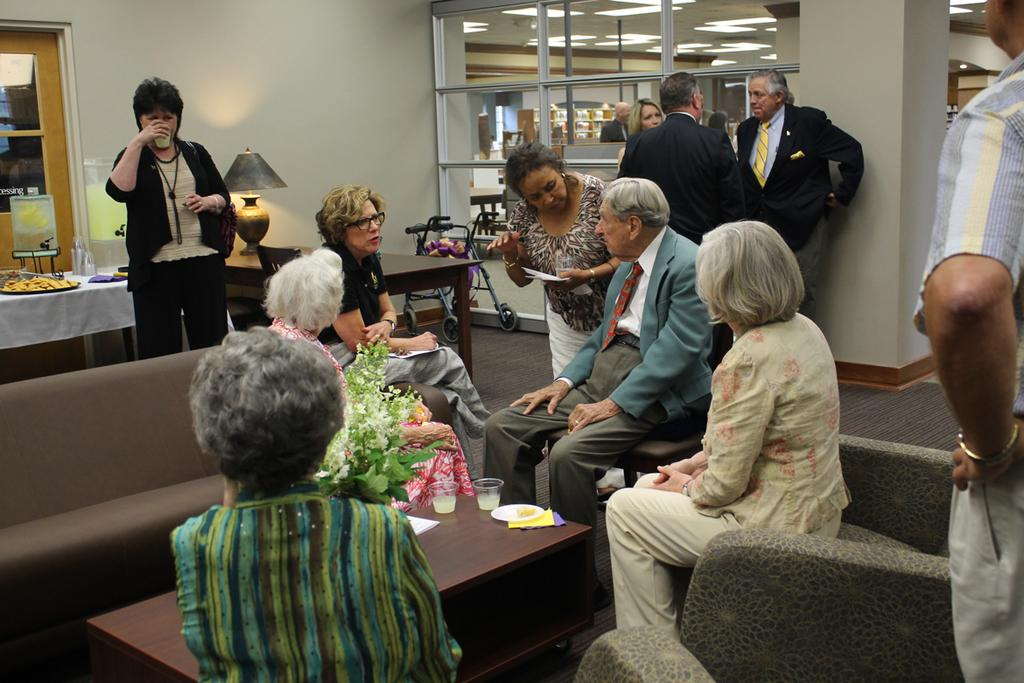What are the people in the room doing? There are people sitting in the room. Are there any people standing in the room? Yes, there are people standing in the background of the room. What type of furniture is present in the room? There are sofas and a table in the room. What additional items can be seen in the room? There is a stroller, a lamp, and a door in the room. What type of pancake is being served to the police in the room? There is no pancake or police present in the image; it only shows people sitting and standing in a room with various furniture and items. 